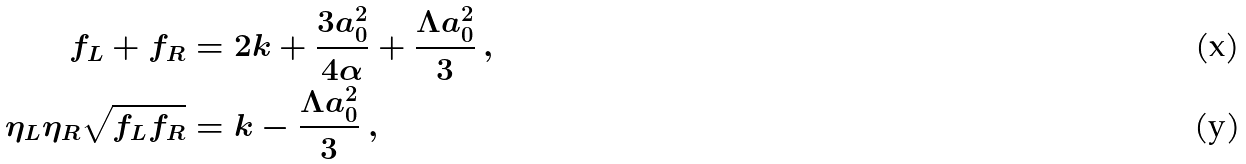Convert formula to latex. <formula><loc_0><loc_0><loc_500><loc_500>f _ { L } + f _ { R } & = 2 k + \frac { 3 a _ { 0 } ^ { 2 } } { 4 \alpha } + \frac { \Lambda a _ { 0 } ^ { 2 } } { 3 } \ , \\ \eta _ { L } \eta _ { R } \sqrt { f _ { L } f _ { R } } & = k - \frac { \Lambda a _ { 0 } ^ { 2 } } { 3 } \ ,</formula> 